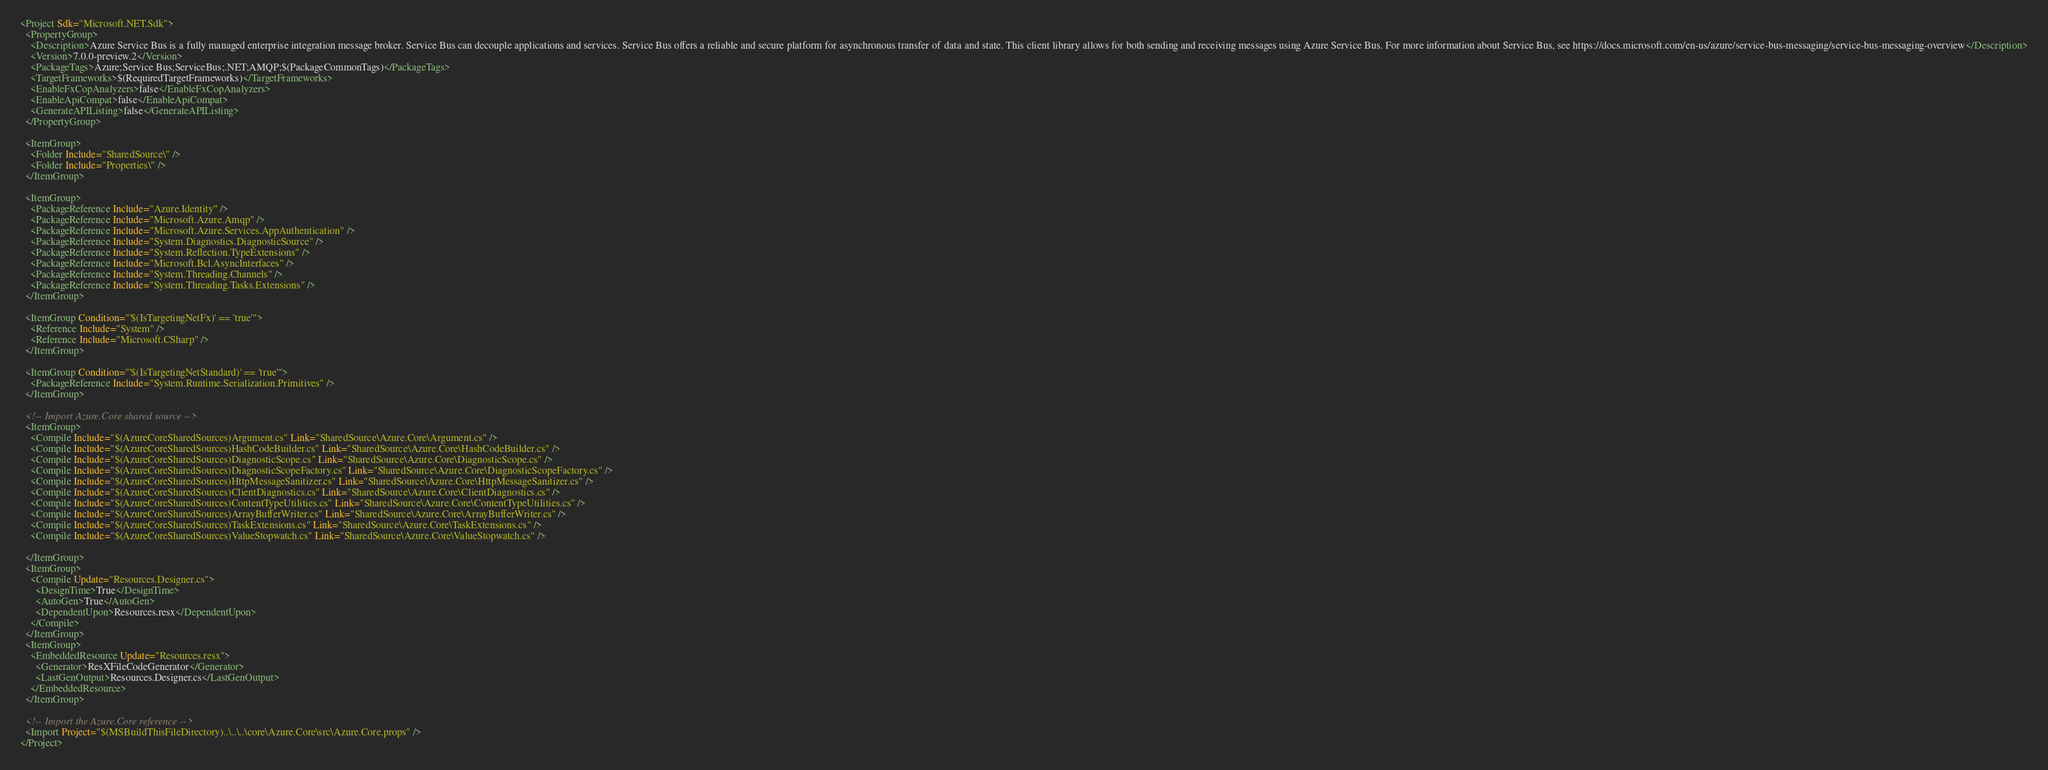<code> <loc_0><loc_0><loc_500><loc_500><_XML_><Project Sdk="Microsoft.NET.Sdk">
  <PropertyGroup>
    <Description>Azure Service Bus is a fully managed enterprise integration message broker. Service Bus can decouple applications and services. Service Bus offers a reliable and secure platform for asynchronous transfer of data and state. This client library allows for both sending and receiving messages using Azure Service Bus. For more information about Service Bus, see https://docs.microsoft.com/en-us/azure/service-bus-messaging/service-bus-messaging-overview</Description>
    <Version>7.0.0-preview.2</Version>
    <PackageTags>Azure;Service Bus;ServiceBus;.NET;AMQP;$(PackageCommonTags)</PackageTags>
    <TargetFrameworks>$(RequiredTargetFrameworks)</TargetFrameworks>
    <EnableFxCopAnalyzers>false</EnableFxCopAnalyzers>
    <EnableApiCompat>false</EnableApiCompat>
    <GenerateAPIListing>false</GenerateAPIListing>
  </PropertyGroup>

  <ItemGroup>
    <Folder Include="SharedSource\" />
    <Folder Include="Properties\" />
  </ItemGroup>

  <ItemGroup>
    <PackageReference Include="Azure.Identity" />
    <PackageReference Include="Microsoft.Azure.Amqp" />
    <PackageReference Include="Microsoft.Azure.Services.AppAuthentication" />
    <PackageReference Include="System.Diagnostics.DiagnosticSource" />
    <PackageReference Include="System.Reflection.TypeExtensions" />
    <PackageReference Include="Microsoft.Bcl.AsyncInterfaces" />
    <PackageReference Include="System.Threading.Channels" />
    <PackageReference Include="System.Threading.Tasks.Extensions" />
  </ItemGroup>

  <ItemGroup Condition="'$(IsTargetingNetFx)' == 'true'">
    <Reference Include="System" />
    <Reference Include="Microsoft.CSharp" />
  </ItemGroup>

  <ItemGroup Condition="'$(IsTargetingNetStandard)' == 'true'">
    <PackageReference Include="System.Runtime.Serialization.Primitives" />
  </ItemGroup>

  <!-- Import Azure.Core shared source -->
  <ItemGroup>
    <Compile Include="$(AzureCoreSharedSources)Argument.cs" Link="SharedSource\Azure.Core\Argument.cs" />
    <Compile Include="$(AzureCoreSharedSources)HashCodeBuilder.cs" Link="SharedSource\Azure.Core\HashCodeBuilder.cs" />
    <Compile Include="$(AzureCoreSharedSources)DiagnosticScope.cs" Link="SharedSource\Azure.Core\DiagnosticScope.cs" />
    <Compile Include="$(AzureCoreSharedSources)DiagnosticScopeFactory.cs" Link="SharedSource\Azure.Core\DiagnosticScopeFactory.cs" />
    <Compile Include="$(AzureCoreSharedSources)HttpMessageSanitizer.cs" Link="SharedSource\Azure.Core\HttpMessageSanitizer.cs" />
    <Compile Include="$(AzureCoreSharedSources)ClientDiagnostics.cs" Link="SharedSource\Azure.Core\ClientDiagnostics.cs" />
    <Compile Include="$(AzureCoreSharedSources)ContentTypeUtilities.cs" Link="SharedSource\Azure.Core\ContentTypeUtilities.cs" />
    <Compile Include="$(AzureCoreSharedSources)ArrayBufferWriter.cs" Link="SharedSource\Azure.Core\ArrayBufferWriter.cs" />
    <Compile Include="$(AzureCoreSharedSources)TaskExtensions.cs" Link="SharedSource\Azure.Core\TaskExtensions.cs" />
    <Compile Include="$(AzureCoreSharedSources)ValueStopwatch.cs" Link="SharedSource\Azure.Core\ValueStopwatch.cs" />

  </ItemGroup>
  <ItemGroup>
    <Compile Update="Resources.Designer.cs">
      <DesignTime>True</DesignTime>
      <AutoGen>True</AutoGen>
      <DependentUpon>Resources.resx</DependentUpon>
    </Compile>
  </ItemGroup>
  <ItemGroup>
    <EmbeddedResource Update="Resources.resx">
      <Generator>ResXFileCodeGenerator</Generator>
      <LastGenOutput>Resources.Designer.cs</LastGenOutput>
    </EmbeddedResource>
  </ItemGroup>

  <!-- Import the Azure.Core reference -->
  <Import Project="$(MSBuildThisFileDirectory)..\..\..\core\Azure.Core\src\Azure.Core.props" />
</Project>
</code> 